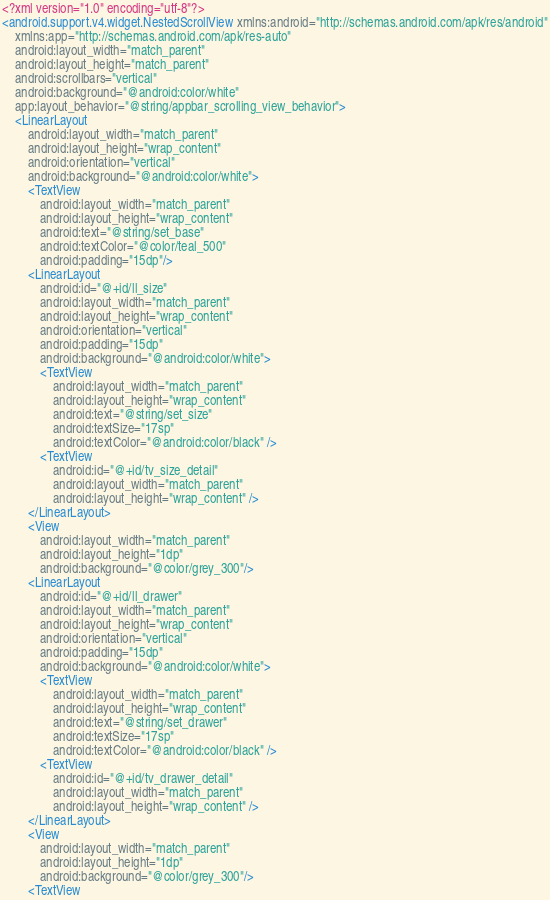Convert code to text. <code><loc_0><loc_0><loc_500><loc_500><_XML_><?xml version="1.0" encoding="utf-8"?>
<android.support.v4.widget.NestedScrollView xmlns:android="http://schemas.android.com/apk/res/android"
    xmlns:app="http://schemas.android.com/apk/res-auto"
    android:layout_width="match_parent"
    android:layout_height="match_parent"
    android:scrollbars="vertical"
    android:background="@android:color/white"
    app:layout_behavior="@string/appbar_scrolling_view_behavior">
    <LinearLayout
        android:layout_width="match_parent"
        android:layout_height="wrap_content"
        android:orientation="vertical"
        android:background="@android:color/white">
        <TextView
            android:layout_width="match_parent"
            android:layout_height="wrap_content"
            android:text="@string/set_base"
            android:textColor="@color/teal_500"
            android:padding="15dp"/>
        <LinearLayout
            android:id="@+id/ll_size"
            android:layout_width="match_parent"
            android:layout_height="wrap_content"
            android:orientation="vertical"
            android:padding="15dp"
            android:background="@android:color/white">
            <TextView
                android:layout_width="match_parent"
                android:layout_height="wrap_content"
                android:text="@string/set_size"
                android:textSize="17sp"
                android:textColor="@android:color/black" />
            <TextView
                android:id="@+id/tv_size_detail"
                android:layout_width="match_parent"
                android:layout_height="wrap_content" />
        </LinearLayout>
        <View
            android:layout_width="match_parent"
            android:layout_height="1dp"
            android:background="@color/grey_300"/>
        <LinearLayout
            android:id="@+id/ll_drawer"
            android:layout_width="match_parent"
            android:layout_height="wrap_content"
            android:orientation="vertical"
            android:padding="15dp"
            android:background="@android:color/white">
            <TextView
                android:layout_width="match_parent"
                android:layout_height="wrap_content"
                android:text="@string/set_drawer"
                android:textSize="17sp"
                android:textColor="@android:color/black" />
            <TextView
                android:id="@+id/tv_drawer_detail"
                android:layout_width="match_parent"
                android:layout_height="wrap_content" />
        </LinearLayout>
        <View
            android:layout_width="match_parent"
            android:layout_height="1dp"
            android:background="@color/grey_300"/>
        <TextView</code> 